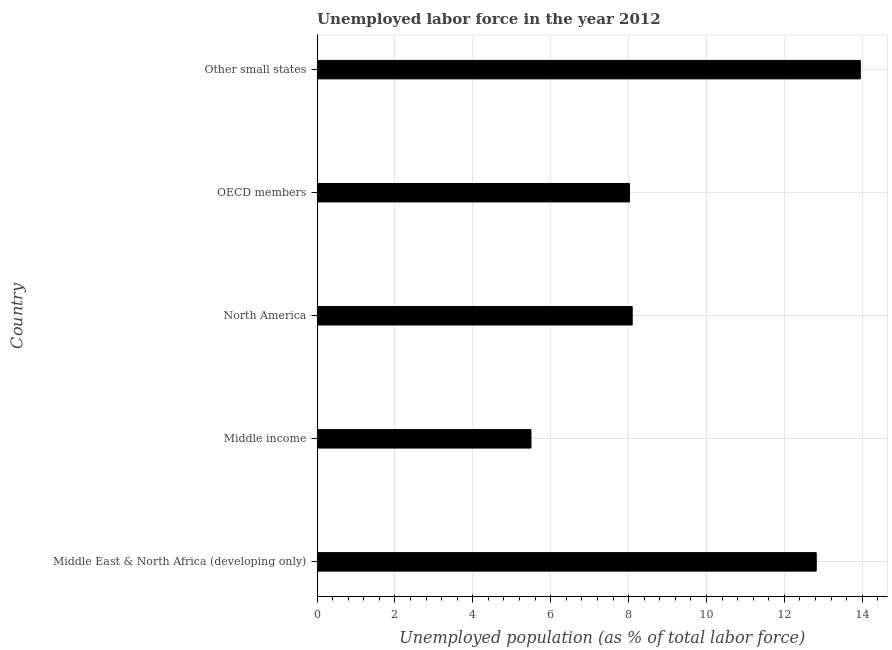What is the title of the graph?
Your answer should be compact. Unemployed labor force in the year 2012. What is the label or title of the X-axis?
Your answer should be compact. Unemployed population (as % of total labor force). What is the total unemployed population in Middle income?
Keep it short and to the point. 5.49. Across all countries, what is the maximum total unemployed population?
Provide a succinct answer. 13.95. Across all countries, what is the minimum total unemployed population?
Give a very brief answer. 5.49. In which country was the total unemployed population maximum?
Give a very brief answer. Other small states. What is the sum of the total unemployed population?
Make the answer very short. 48.37. What is the difference between the total unemployed population in Middle East & North Africa (developing only) and North America?
Make the answer very short. 4.72. What is the average total unemployed population per country?
Keep it short and to the point. 9.68. What is the median total unemployed population?
Your response must be concise. 8.09. What is the ratio of the total unemployed population in Middle East & North Africa (developing only) to that in Middle income?
Offer a very short reply. 2.33. What is the difference between the highest and the second highest total unemployed population?
Your response must be concise. 1.13. Is the sum of the total unemployed population in OECD members and Other small states greater than the maximum total unemployed population across all countries?
Offer a very short reply. Yes. What is the difference between the highest and the lowest total unemployed population?
Ensure brevity in your answer.  8.46. In how many countries, is the total unemployed population greater than the average total unemployed population taken over all countries?
Your response must be concise. 2. How many bars are there?
Offer a very short reply. 5. Are all the bars in the graph horizontal?
Offer a very short reply. Yes. What is the difference between two consecutive major ticks on the X-axis?
Your response must be concise. 2. What is the Unemployed population (as % of total labor force) in Middle East & North Africa (developing only)?
Your answer should be compact. 12.82. What is the Unemployed population (as % of total labor force) of Middle income?
Offer a very short reply. 5.49. What is the Unemployed population (as % of total labor force) of North America?
Your answer should be compact. 8.09. What is the Unemployed population (as % of total labor force) of OECD members?
Offer a very short reply. 8.02. What is the Unemployed population (as % of total labor force) of Other small states?
Offer a terse response. 13.95. What is the difference between the Unemployed population (as % of total labor force) in Middle East & North Africa (developing only) and Middle income?
Give a very brief answer. 7.32. What is the difference between the Unemployed population (as % of total labor force) in Middle East & North Africa (developing only) and North America?
Provide a short and direct response. 4.73. What is the difference between the Unemployed population (as % of total labor force) in Middle East & North Africa (developing only) and OECD members?
Ensure brevity in your answer.  4.8. What is the difference between the Unemployed population (as % of total labor force) in Middle East & North Africa (developing only) and Other small states?
Offer a very short reply. -1.13. What is the difference between the Unemployed population (as % of total labor force) in Middle income and North America?
Ensure brevity in your answer.  -2.6. What is the difference between the Unemployed population (as % of total labor force) in Middle income and OECD members?
Your response must be concise. -2.53. What is the difference between the Unemployed population (as % of total labor force) in Middle income and Other small states?
Your answer should be compact. -8.46. What is the difference between the Unemployed population (as % of total labor force) in North America and OECD members?
Offer a very short reply. 0.07. What is the difference between the Unemployed population (as % of total labor force) in North America and Other small states?
Your answer should be very brief. -5.86. What is the difference between the Unemployed population (as % of total labor force) in OECD members and Other small states?
Your answer should be compact. -5.93. What is the ratio of the Unemployed population (as % of total labor force) in Middle East & North Africa (developing only) to that in Middle income?
Keep it short and to the point. 2.33. What is the ratio of the Unemployed population (as % of total labor force) in Middle East & North Africa (developing only) to that in North America?
Make the answer very short. 1.58. What is the ratio of the Unemployed population (as % of total labor force) in Middle East & North Africa (developing only) to that in OECD members?
Provide a short and direct response. 1.6. What is the ratio of the Unemployed population (as % of total labor force) in Middle East & North Africa (developing only) to that in Other small states?
Your response must be concise. 0.92. What is the ratio of the Unemployed population (as % of total labor force) in Middle income to that in North America?
Provide a short and direct response. 0.68. What is the ratio of the Unemployed population (as % of total labor force) in Middle income to that in OECD members?
Your response must be concise. 0.69. What is the ratio of the Unemployed population (as % of total labor force) in Middle income to that in Other small states?
Provide a short and direct response. 0.39. What is the ratio of the Unemployed population (as % of total labor force) in North America to that in OECD members?
Give a very brief answer. 1.01. What is the ratio of the Unemployed population (as % of total labor force) in North America to that in Other small states?
Provide a short and direct response. 0.58. What is the ratio of the Unemployed population (as % of total labor force) in OECD members to that in Other small states?
Offer a terse response. 0.57. 